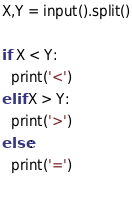<code> <loc_0><loc_0><loc_500><loc_500><_Python_>X,Y = input().split()

if X < Y:
  print('<')
elif X > Y:
  print('>')
else:
  print('=')
  </code> 